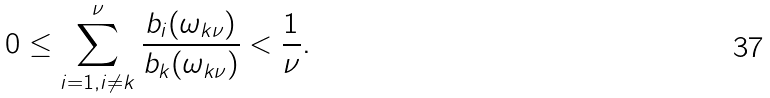Convert formula to latex. <formula><loc_0><loc_0><loc_500><loc_500>0 \leq \sum _ { i = 1 , i \neq k } ^ { \nu } \frac { b _ { i } ( \omega _ { k \nu } ) } { b _ { k } ( \omega _ { k \nu } ) } < \frac { 1 } { \nu } .</formula> 